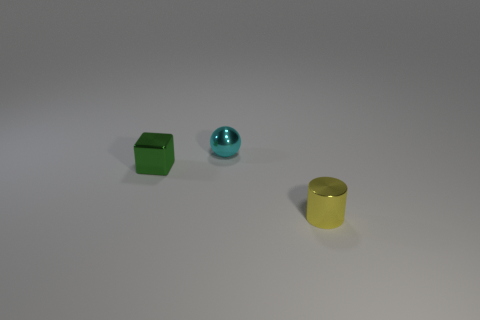Add 2 big cyan matte things. How many objects exist? 5 Subtract all cylinders. How many objects are left? 2 Add 3 small spheres. How many small spheres exist? 4 Subtract 1 yellow cylinders. How many objects are left? 2 Subtract all cyan metal things. Subtract all tiny yellow shiny objects. How many objects are left? 1 Add 2 yellow shiny objects. How many yellow shiny objects are left? 3 